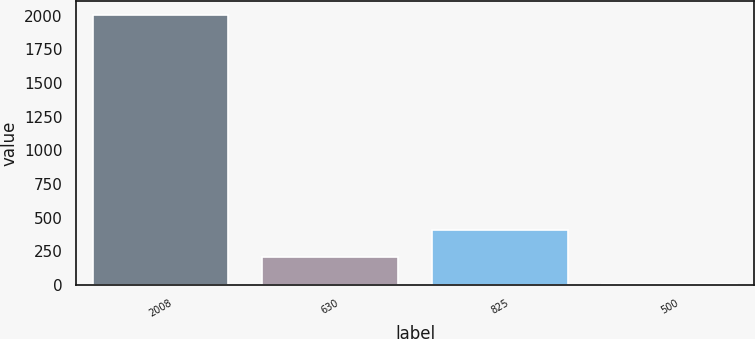Convert chart to OTSL. <chart><loc_0><loc_0><loc_500><loc_500><bar_chart><fcel>2008<fcel>630<fcel>825<fcel>500<nl><fcel>2007<fcel>205.2<fcel>405.4<fcel>5<nl></chart> 